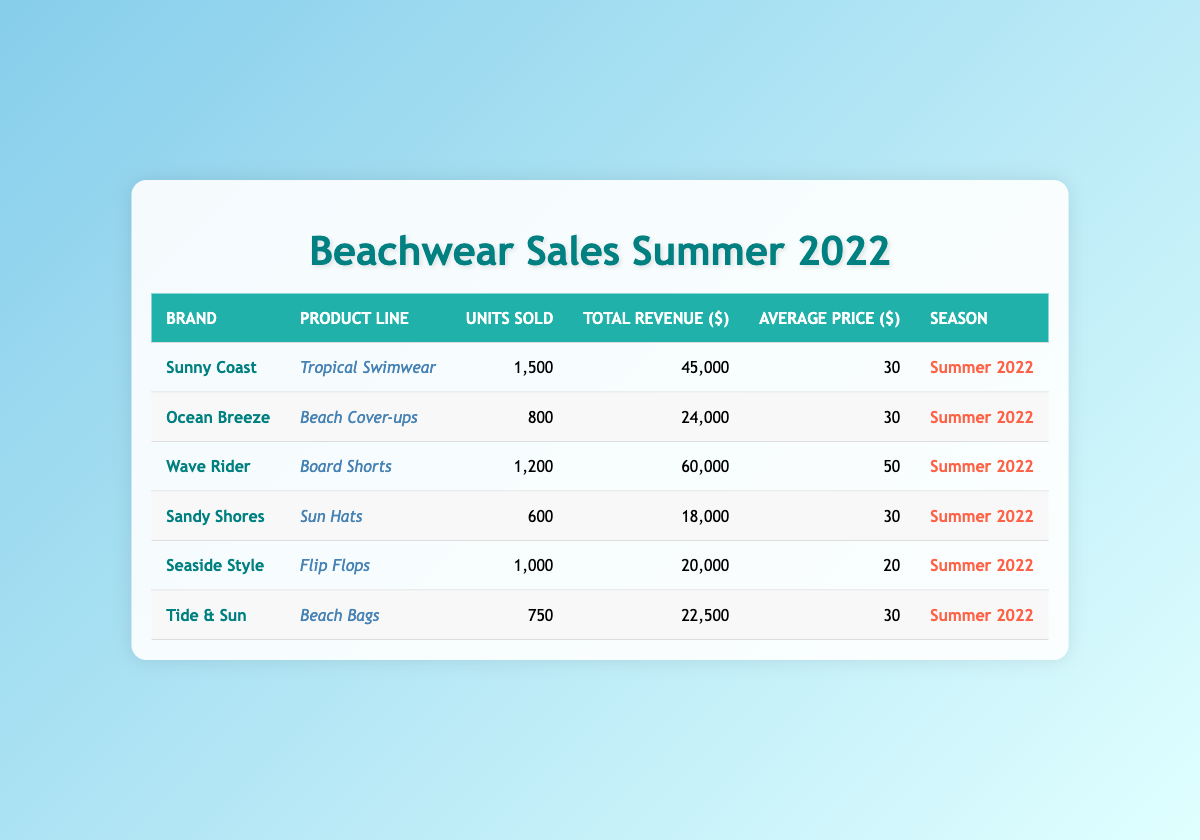What is the total revenue generated by Wave Rider? According to the table, Wave Rider has a total revenue of 60,000 dollars for its Board Shorts product line.
Answer: 60,000 How many units of Tropical Swimwear were sold? The table indicates that Sunny Coast sold 1,500 units of Tropical Swimwear.
Answer: 1,500 Which brand had the highest average price per unit? By examining the average prices, Wave Rider's Board Shorts have the highest average price at 50 dollars compared to other products listed.
Answer: Wave Rider What is the total number of units sold across all brands? We need to sum the units sold from each brand: 1,500 + 800 + 1,200 + 600 + 1,000 + 750 = 5,850. Therefore, the total number of units sold across all brands is 5,850.
Answer: 5,850 Did Sandy Shores generate more revenue than Ocean Breeze? Sandy Shores generated 18,000 dollars while Ocean Breeze generated 24,000 dollars. Therefore, Sandy Shores did not generate more revenue than Ocean Breeze.
Answer: No What is the average revenue generated per unit sold for Seaside Style's Flip Flops? The average price for Seaside Style's Flip Flops is 20 dollars. To find total revenue, we need to multiply units sold (1,000) by average price: 1,000 * 20 = 20,000. The average revenue per unit is already given as 20 dollars, which matches the calculation.
Answer: 20 Which brand sold the least number of units and how many were sold? Looking at the units sold for each brand, Sandy Shores sold the least with only 600 units of Sun Hats.
Answer: 600 What percent of the total revenue does Tropical Swimwear contribute? To find the percentage of total revenue from Tropical Swimwear, we first calculate total revenue: 60,000 + 45,000 + 24,000 + 18,000 + 20,000 + 22,500 = 189,500. Tropical Swimwear revenue is 45,000. The percentage can be calculated as (45,000 / 189,500)*100 = 23.7%.
Answer: 23.7% 